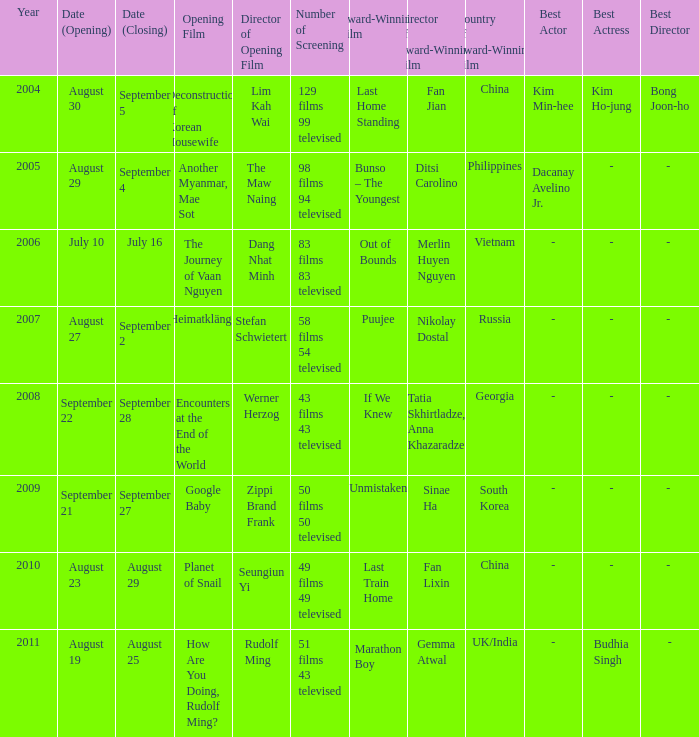What is the award-winning film that has been screened as 50 films and 50 television broadcasts? Unmistaken. 